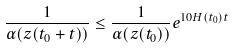<formula> <loc_0><loc_0><loc_500><loc_500>\frac { 1 } { \alpha ( z ( t _ { 0 } + t ) ) } \leq \frac { 1 } { \alpha ( z ( t _ { 0 } ) ) } e ^ { 1 0 H ( t _ { 0 } ) t }</formula> 